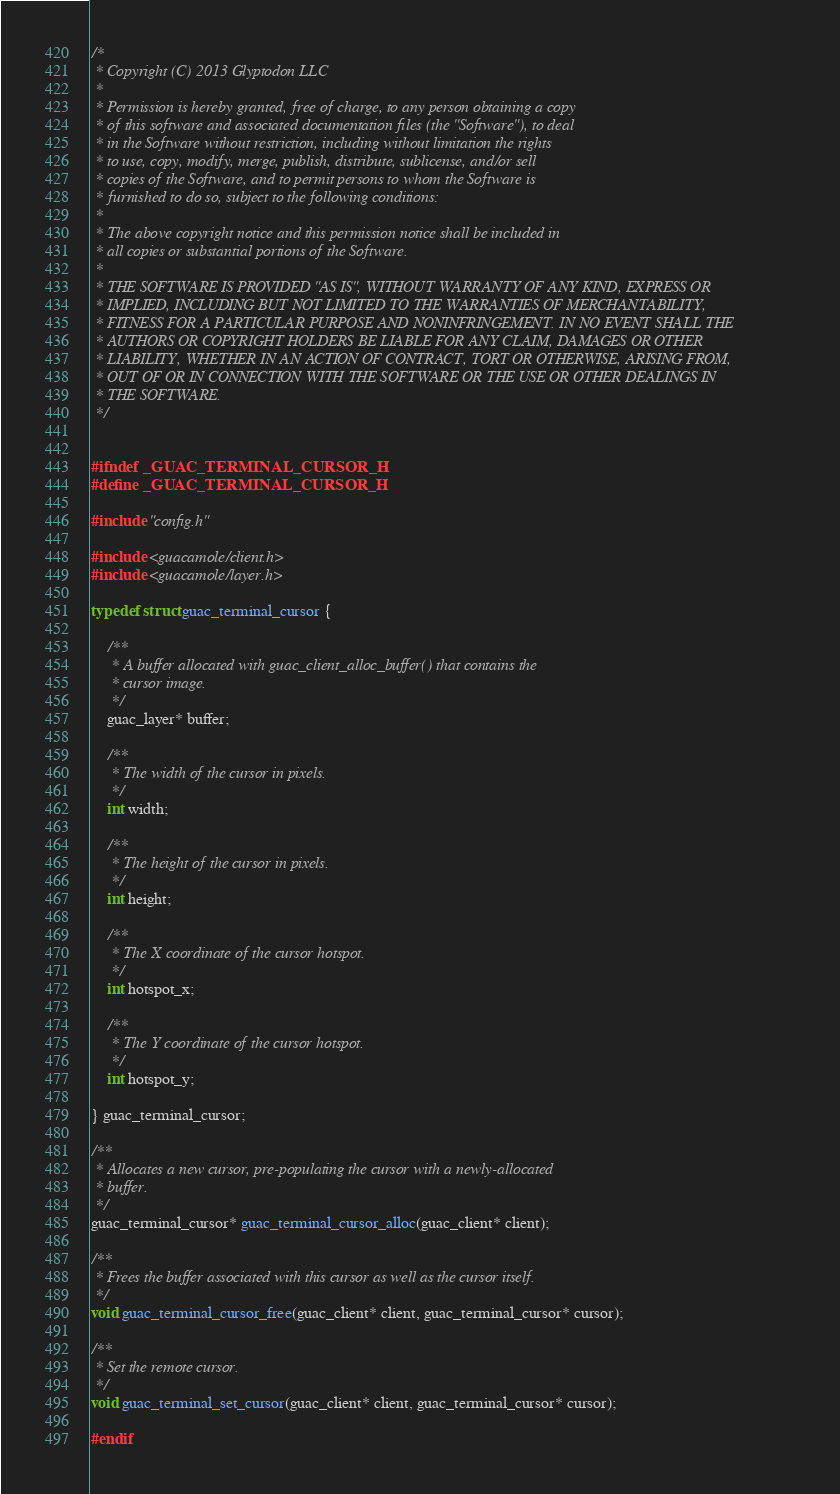Convert code to text. <code><loc_0><loc_0><loc_500><loc_500><_C_>/*
 * Copyright (C) 2013 Glyptodon LLC
 *
 * Permission is hereby granted, free of charge, to any person obtaining a copy
 * of this software and associated documentation files (the "Software"), to deal
 * in the Software without restriction, including without limitation the rights
 * to use, copy, modify, merge, publish, distribute, sublicense, and/or sell
 * copies of the Software, and to permit persons to whom the Software is
 * furnished to do so, subject to the following conditions:
 *
 * The above copyright notice and this permission notice shall be included in
 * all copies or substantial portions of the Software.
 *
 * THE SOFTWARE IS PROVIDED "AS IS", WITHOUT WARRANTY OF ANY KIND, EXPRESS OR
 * IMPLIED, INCLUDING BUT NOT LIMITED TO THE WARRANTIES OF MERCHANTABILITY,
 * FITNESS FOR A PARTICULAR PURPOSE AND NONINFRINGEMENT. IN NO EVENT SHALL THE
 * AUTHORS OR COPYRIGHT HOLDERS BE LIABLE FOR ANY CLAIM, DAMAGES OR OTHER
 * LIABILITY, WHETHER IN AN ACTION OF CONTRACT, TORT OR OTHERWISE, ARISING FROM,
 * OUT OF OR IN CONNECTION WITH THE SOFTWARE OR THE USE OR OTHER DEALINGS IN
 * THE SOFTWARE.
 */


#ifndef _GUAC_TERMINAL_CURSOR_H
#define _GUAC_TERMINAL_CURSOR_H

#include "config.h"

#include <guacamole/client.h>
#include <guacamole/layer.h>

typedef struct guac_terminal_cursor {

    /**
     * A buffer allocated with guac_client_alloc_buffer() that contains the
     * cursor image.
     */
    guac_layer* buffer;

    /**
     * The width of the cursor in pixels.
     */
    int width;

    /**
     * The height of the cursor in pixels.
     */
    int height;

    /**
     * The X coordinate of the cursor hotspot.
     */
    int hotspot_x;

    /**
     * The Y coordinate of the cursor hotspot.
     */
    int hotspot_y;

} guac_terminal_cursor;

/**
 * Allocates a new cursor, pre-populating the cursor with a newly-allocated
 * buffer.
 */
guac_terminal_cursor* guac_terminal_cursor_alloc(guac_client* client);

/**
 * Frees the buffer associated with this cursor as well as the cursor itself.
 */
void guac_terminal_cursor_free(guac_client* client, guac_terminal_cursor* cursor);

/**
 * Set the remote cursor.
 */
void guac_terminal_set_cursor(guac_client* client, guac_terminal_cursor* cursor);

#endif
</code> 